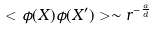Convert formula to latex. <formula><loc_0><loc_0><loc_500><loc_500>< \phi ( X ) \phi ( X ^ { \prime } ) > \sim r ^ { - \frac { \alpha } { d } }</formula> 